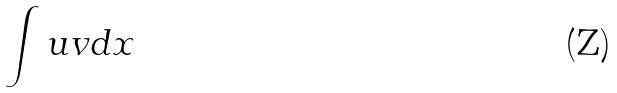Convert formula to latex. <formula><loc_0><loc_0><loc_500><loc_500>\int u v d x</formula> 